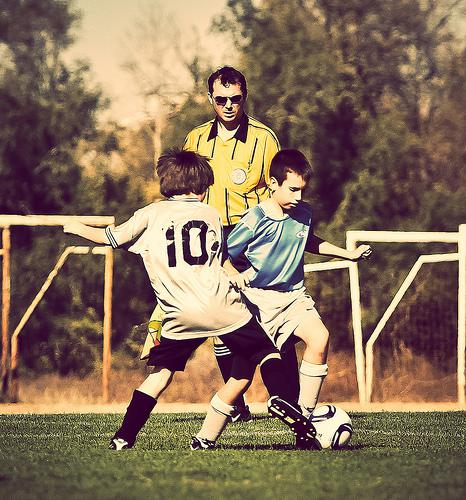Question: where are they?
Choices:
A. Baseball field.
B. Tennis court.
C. Soccer field.
D. Gym.
Answer with the letter. Answer: C Question: why are the kids wearing different shirts?
Choices:
A. Different teams.
B. The same style shirt was not available in all the right sizes.
C. Each shirt color represents a different team.
D. Each child chose their own favorite shirt.
Answer with the letter. Answer: A Question: what game are they playing?
Choices:
A. Soccer.
B. Baseball.
C. Tag.
D. Monopoly.
Answer with the letter. Answer: A Question: what number is on the shirt?
Choices:
A. Twenty.
B. Ten.
C. Seven.
D. Twelve.
Answer with the letter. Answer: B Question: what color is the grass?
Choices:
A. Red.
B. Green.
C. White.
D. Blue.
Answer with the letter. Answer: B Question: who is the guy in the yellow?
Choices:
A. Referee.
B. Minion.
C. A worker in a HazMat suit.
D. A crossing guard.
Answer with the letter. Answer: A 